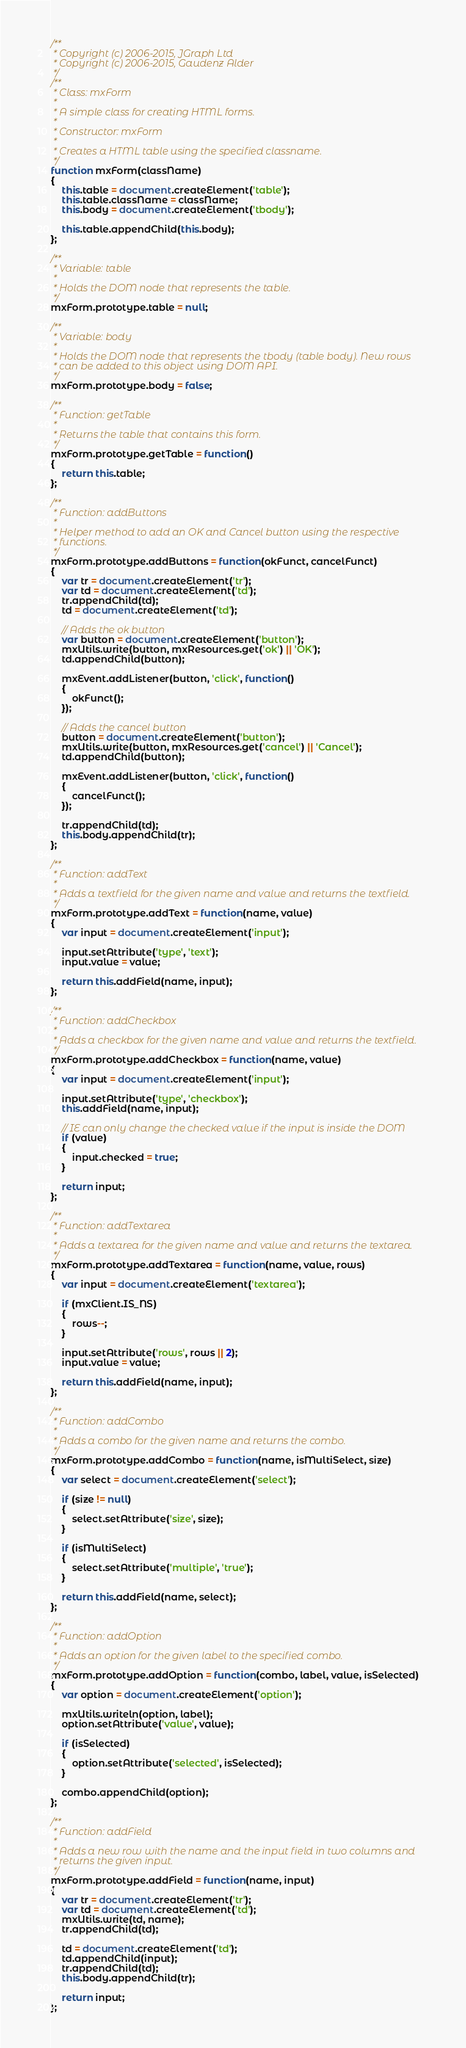Convert code to text. <code><loc_0><loc_0><loc_500><loc_500><_JavaScript_>/**
 * Copyright (c) 2006-2015, JGraph Ltd
 * Copyright (c) 2006-2015, Gaudenz Alder
 */
/**
 * Class: mxForm
 * 
 * A simple class for creating HTML forms.
 * 
 * Constructor: mxForm
 * 
 * Creates a HTML table using the specified classname.
 */
function mxForm(className)
{
	this.table = document.createElement('table');
	this.table.className = className;
	this.body = document.createElement('tbody');
	
	this.table.appendChild(this.body);
};

/**
 * Variable: table
 * 
 * Holds the DOM node that represents the table.
 */
mxForm.prototype.table = null;

/**
 * Variable: body
 * 
 * Holds the DOM node that represents the tbody (table body). New rows
 * can be added to this object using DOM API.
 */
mxForm.prototype.body = false;

/**
 * Function: getTable
 * 
 * Returns the table that contains this form.
 */
mxForm.prototype.getTable = function()
{
	return this.table;
};

/**
 * Function: addButtons
 * 
 * Helper method to add an OK and Cancel button using the respective
 * functions.
 */
mxForm.prototype.addButtons = function(okFunct, cancelFunct)
{
	var tr = document.createElement('tr');
	var td = document.createElement('td');
	tr.appendChild(td);
	td = document.createElement('td');

	// Adds the ok button
	var button = document.createElement('button');
	mxUtils.write(button, mxResources.get('ok') || 'OK');
	td.appendChild(button);

	mxEvent.addListener(button, 'click', function()
	{
		okFunct();
	});
	
	// Adds the cancel button
	button = document.createElement('button');
	mxUtils.write(button, mxResources.get('cancel') || 'Cancel');
	td.appendChild(button);
	
	mxEvent.addListener(button, 'click', function()
	{
		cancelFunct();
	});
	
	tr.appendChild(td);
	this.body.appendChild(tr);
};

/**
 * Function: addText
 * 
 * Adds a textfield for the given name and value and returns the textfield.
 */
mxForm.prototype.addText = function(name, value)
{
	var input = document.createElement('input');
	
	input.setAttribute('type', 'text');
	input.value = value;
	
	return this.addField(name, input);
};

/**
 * Function: addCheckbox
 * 
 * Adds a checkbox for the given name and value and returns the textfield.
 */
mxForm.prototype.addCheckbox = function(name, value)
{
	var input = document.createElement('input');
	
	input.setAttribute('type', 'checkbox');
	this.addField(name, input);

	// IE can only change the checked value if the input is inside the DOM
	if (value)
	{
		input.checked = true;
	}

	return input;
};

/**
 * Function: addTextarea
 * 
 * Adds a textarea for the given name and value and returns the textarea.
 */
mxForm.prototype.addTextarea = function(name, value, rows)
{
	var input = document.createElement('textarea');
	
	if (mxClient.IS_NS)
	{
		rows--;
	}
	
	input.setAttribute('rows', rows || 2);
	input.value = value;
	
	return this.addField(name, input);
};

/**
 * Function: addCombo
 * 
 * Adds a combo for the given name and returns the combo.
 */
mxForm.prototype.addCombo = function(name, isMultiSelect, size)
{
	var select = document.createElement('select');
	
	if (size != null)
	{
		select.setAttribute('size', size);
	}
	
	if (isMultiSelect)
	{
		select.setAttribute('multiple', 'true');
	}
	
	return this.addField(name, select);
};

/**
 * Function: addOption
 * 
 * Adds an option for the given label to the specified combo.
 */
mxForm.prototype.addOption = function(combo, label, value, isSelected)
{
	var option = document.createElement('option');
	
	mxUtils.writeln(option, label);
	option.setAttribute('value', value);
	
	if (isSelected)
	{
		option.setAttribute('selected', isSelected);
	}
	
	combo.appendChild(option);
};

/**
 * Function: addField
 * 
 * Adds a new row with the name and the input field in two columns and
 * returns the given input.
 */
mxForm.prototype.addField = function(name, input)
{
	var tr = document.createElement('tr');
	var td = document.createElement('td');
	mxUtils.write(td, name);
	tr.appendChild(td);
	
	td = document.createElement('td');
	td.appendChild(input);
	tr.appendChild(td);
	this.body.appendChild(tr);
	
	return input;
};
</code> 